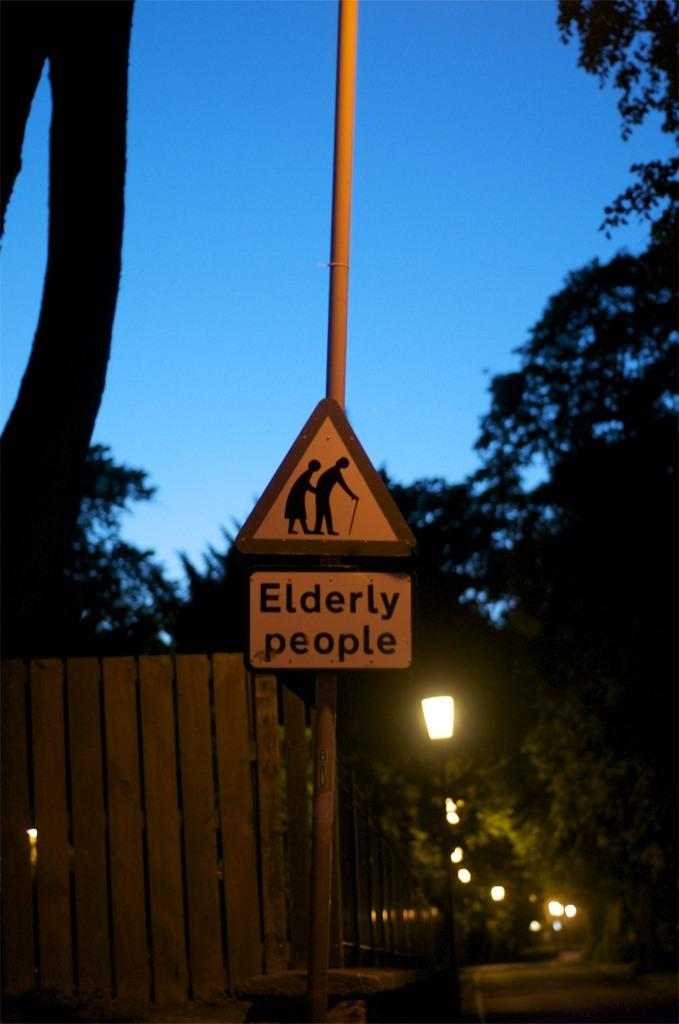What is on the pole in the image? There is a sign board on a pole in the image. What type of lighting is present in the image? There are pole lights in the image. What type of vegetation is visible in the image? There are trees in the image. What type of barrier is present in the image? There is a wooden fence in the image. What is the color of the sky in the image? The sky is blue in the image. What type of curtain is hanging from the trees in the image? There are no curtains present in the image; it features a sign board on a pole, pole lights, trees, a wooden fence, and a blue sky. How many pairs of jeans are visible in the image? There are no jeans present in the image. 